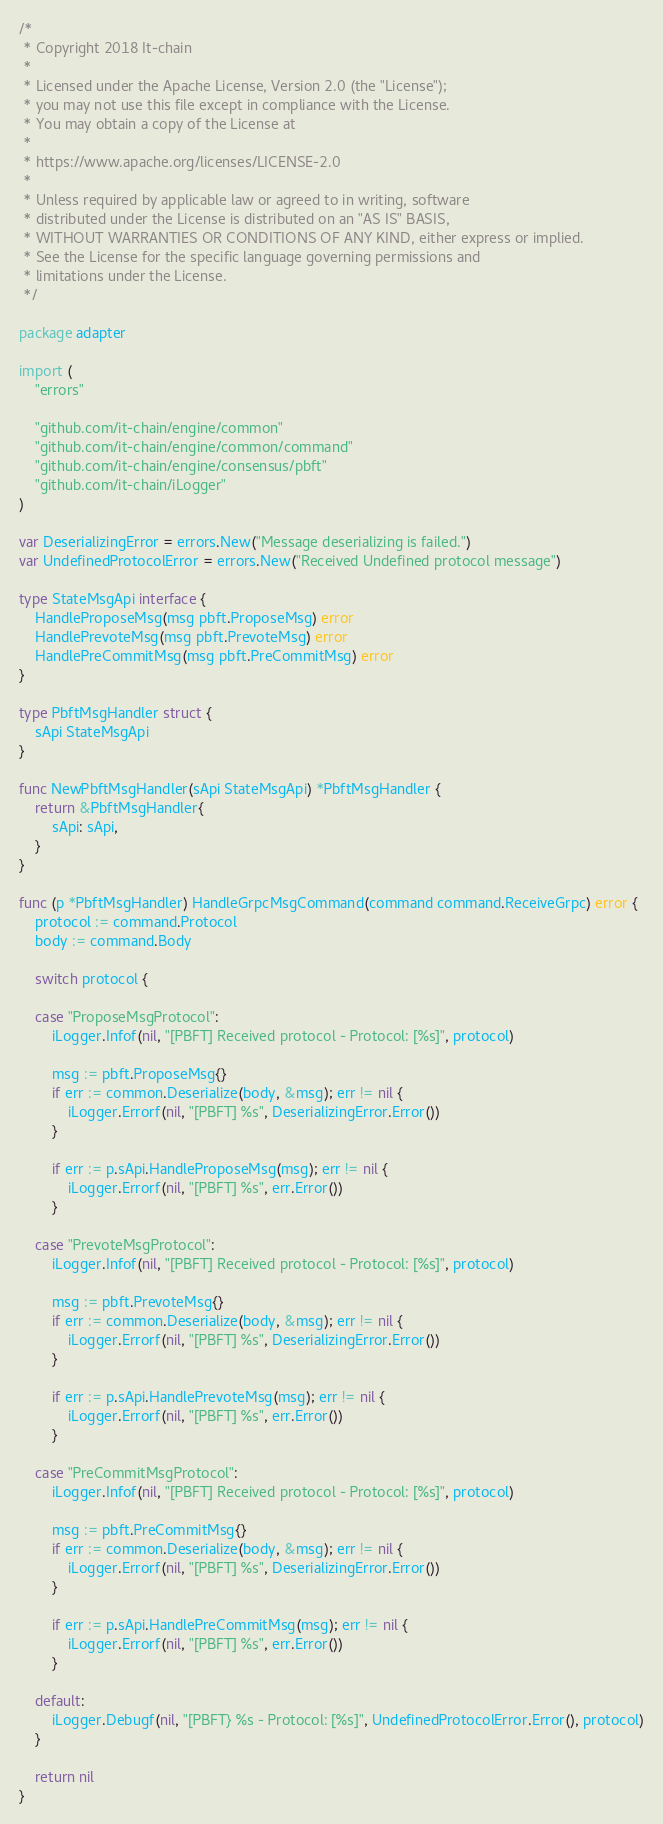<code> <loc_0><loc_0><loc_500><loc_500><_Go_>/*
 * Copyright 2018 It-chain
 *
 * Licensed under the Apache License, Version 2.0 (the "License");
 * you may not use this file except in compliance with the License.
 * You may obtain a copy of the License at
 *
 * https://www.apache.org/licenses/LICENSE-2.0
 *
 * Unless required by applicable law or agreed to in writing, software
 * distributed under the License is distributed on an "AS IS" BASIS,
 * WITHOUT WARRANTIES OR CONDITIONS OF ANY KIND, either express or implied.
 * See the License for the specific language governing permissions and
 * limitations under the License.
 */

package adapter

import (
	"errors"

	"github.com/it-chain/engine/common"
	"github.com/it-chain/engine/common/command"
	"github.com/it-chain/engine/consensus/pbft"
	"github.com/it-chain/iLogger"
)

var DeserializingError = errors.New("Message deserializing is failed.")
var UndefinedProtocolError = errors.New("Received Undefined protocol message")

type StateMsgApi interface {
	HandleProposeMsg(msg pbft.ProposeMsg) error
	HandlePrevoteMsg(msg pbft.PrevoteMsg) error
	HandlePreCommitMsg(msg pbft.PreCommitMsg) error
}

type PbftMsgHandler struct {
	sApi StateMsgApi
}

func NewPbftMsgHandler(sApi StateMsgApi) *PbftMsgHandler {
	return &PbftMsgHandler{
		sApi: sApi,
	}
}

func (p *PbftMsgHandler) HandleGrpcMsgCommand(command command.ReceiveGrpc) error {
	protocol := command.Protocol
	body := command.Body

	switch protocol {

	case "ProposeMsgProtocol":
		iLogger.Infof(nil, "[PBFT] Received protocol - Protocol: [%s]", protocol)

		msg := pbft.ProposeMsg{}
		if err := common.Deserialize(body, &msg); err != nil {
			iLogger.Errorf(nil, "[PBFT] %s", DeserializingError.Error())
		}

		if err := p.sApi.HandleProposeMsg(msg); err != nil {
			iLogger.Errorf(nil, "[PBFT] %s", err.Error())
		}

	case "PrevoteMsgProtocol":
		iLogger.Infof(nil, "[PBFT] Received protocol - Protocol: [%s]", protocol)

		msg := pbft.PrevoteMsg{}
		if err := common.Deserialize(body, &msg); err != nil {
			iLogger.Errorf(nil, "[PBFT] %s", DeserializingError.Error())
		}

		if err := p.sApi.HandlePrevoteMsg(msg); err != nil {
			iLogger.Errorf(nil, "[PBFT] %s", err.Error())
		}

	case "PreCommitMsgProtocol":
		iLogger.Infof(nil, "[PBFT] Received protocol - Protocol: [%s]", protocol)

		msg := pbft.PreCommitMsg{}
		if err := common.Deserialize(body, &msg); err != nil {
			iLogger.Errorf(nil, "[PBFT] %s", DeserializingError.Error())
		}

		if err := p.sApi.HandlePreCommitMsg(msg); err != nil {
			iLogger.Errorf(nil, "[PBFT] %s", err.Error())
		}

	default:
		iLogger.Debugf(nil, "[PBFT} %s - Protocol: [%s]", UndefinedProtocolError.Error(), protocol)
	}

	return nil
}
</code> 